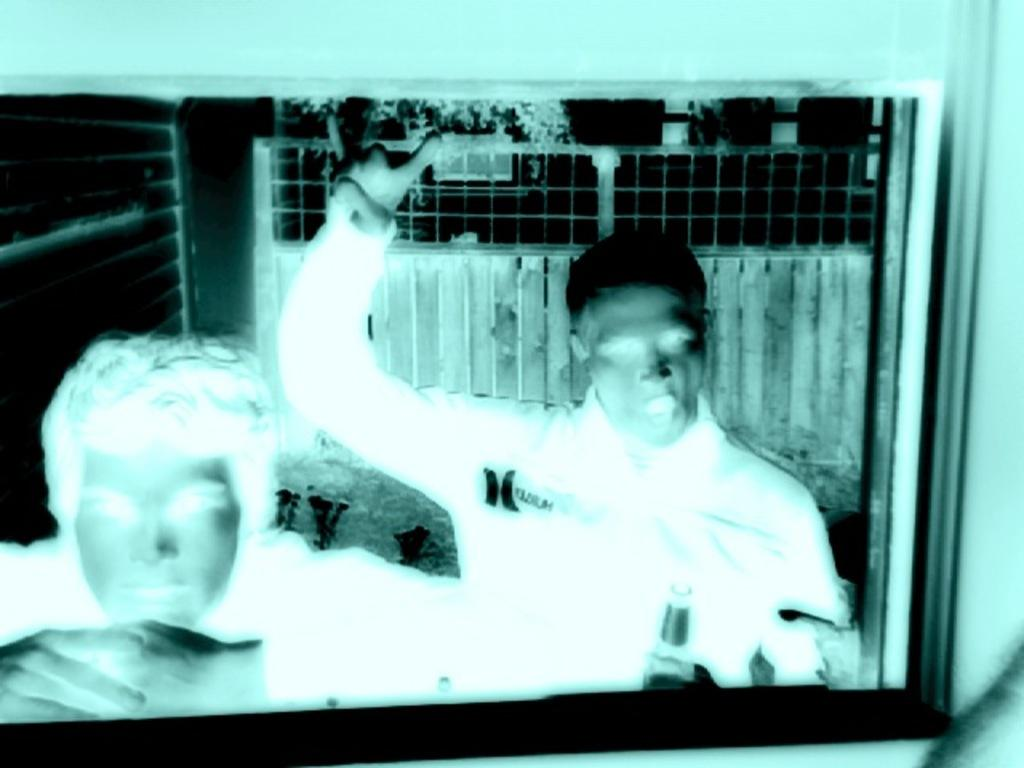What is the main subject of the image? There is a photograph in the image. Who or what is depicted in the photograph? The photograph contains two persons. How is the photograph displayed in the image? There is a photo frame in the image. What can be seen behind the persons in the photograph? Fencing is visible behind the persons in the photograph. What color is the sock on the side of the persons in the photograph? There is no sock visible in the image, as the image only shows a photograph with two persons and a photo frame. 